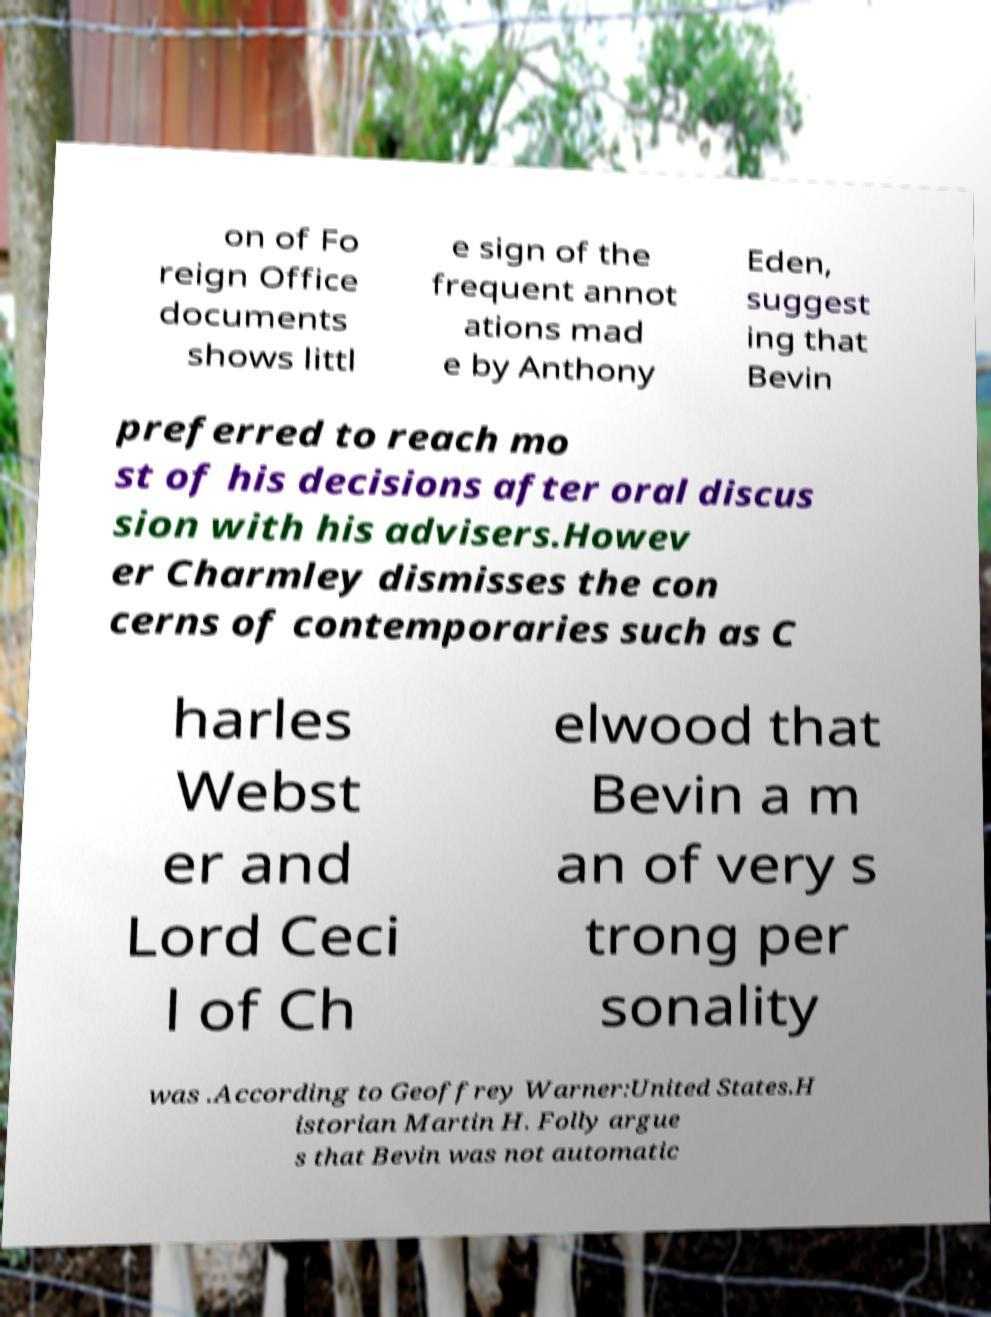Can you accurately transcribe the text from the provided image for me? on of Fo reign Office documents shows littl e sign of the frequent annot ations mad e by Anthony Eden, suggest ing that Bevin preferred to reach mo st of his decisions after oral discus sion with his advisers.Howev er Charmley dismisses the con cerns of contemporaries such as C harles Webst er and Lord Ceci l of Ch elwood that Bevin a m an of very s trong per sonality was .According to Geoffrey Warner:United States.H istorian Martin H. Folly argue s that Bevin was not automatic 